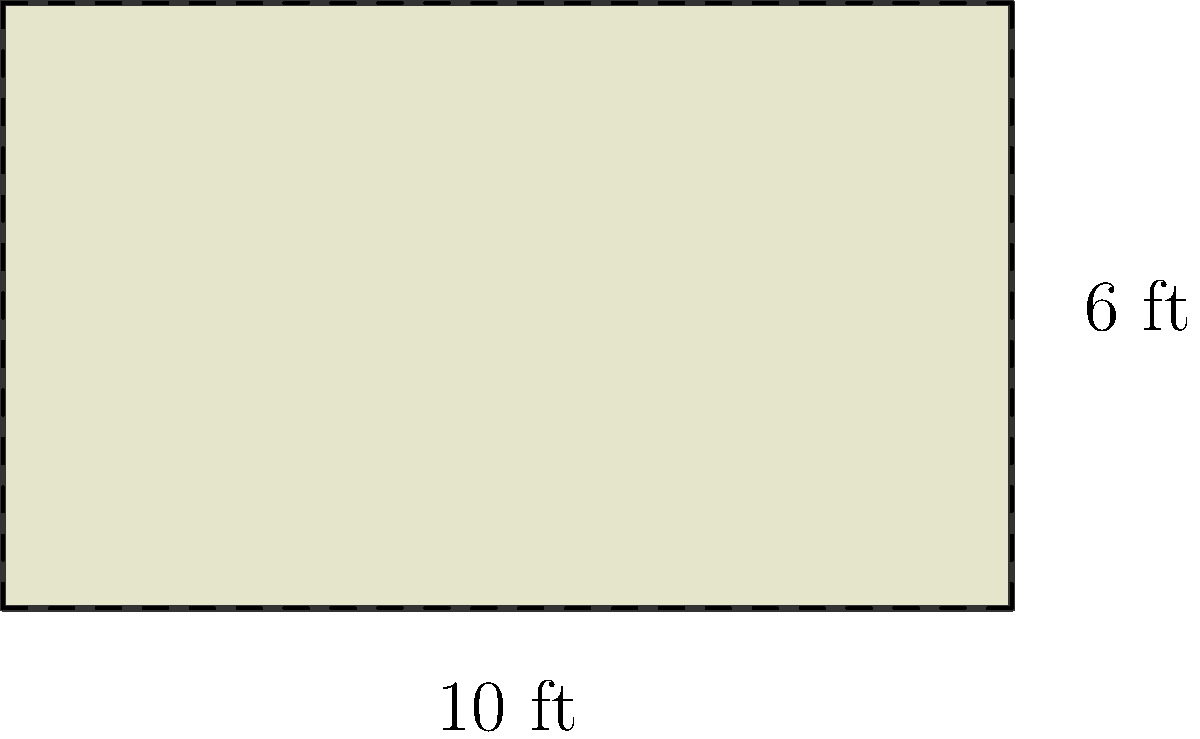As a humor writer inspired by Anne Beatts, you've been tasked with describing a comically oversized novelty check for a sketch. The check measures 10 feet in width and 6 feet in height. What is the area of this hilariously large financial instrument in square feet? (Bonus points if you can think of a witty one-liner about it!) Let's break this down step-by-step, with a dash of humor:

1) The shape of the check is a rectangle. The formula for the area of a rectangle is:

   $$A = l \times w$$

   Where $A$ is the area, $l$ is the length (or height in this case), and $w$ is the width.

2) We're given the dimensions:
   - Width ($w$) = 10 feet
   - Height ($l$) = 6 feet

3) Now, let's plug these values into our formula:

   $$A = 6 \text{ ft} \times 10 \text{ ft}$$

4) Multiply these numbers:

   $$A = 60 \text{ sq ft}$$

5) And there you have it! The area of this oversized check is 60 square feet.

(Humor aside: That's enough space to write a lot of zeros, which is perfect for a comedy sketch about an absurdly large sum of money!)
Answer: 60 sq ft 